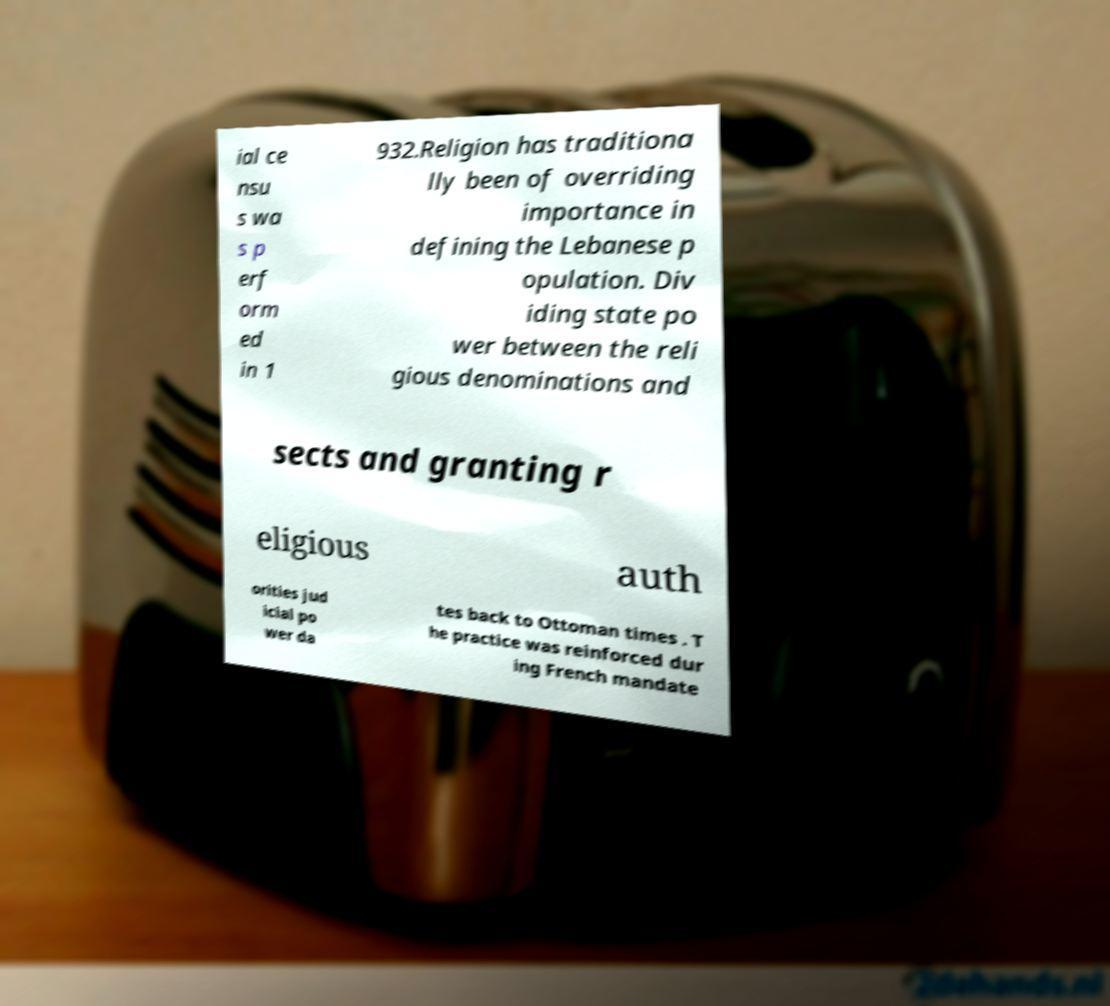Please identify and transcribe the text found in this image. ial ce nsu s wa s p erf orm ed in 1 932.Religion has traditiona lly been of overriding importance in defining the Lebanese p opulation. Div iding state po wer between the reli gious denominations and sects and granting r eligious auth orities jud icial po wer da tes back to Ottoman times . T he practice was reinforced dur ing French mandate 